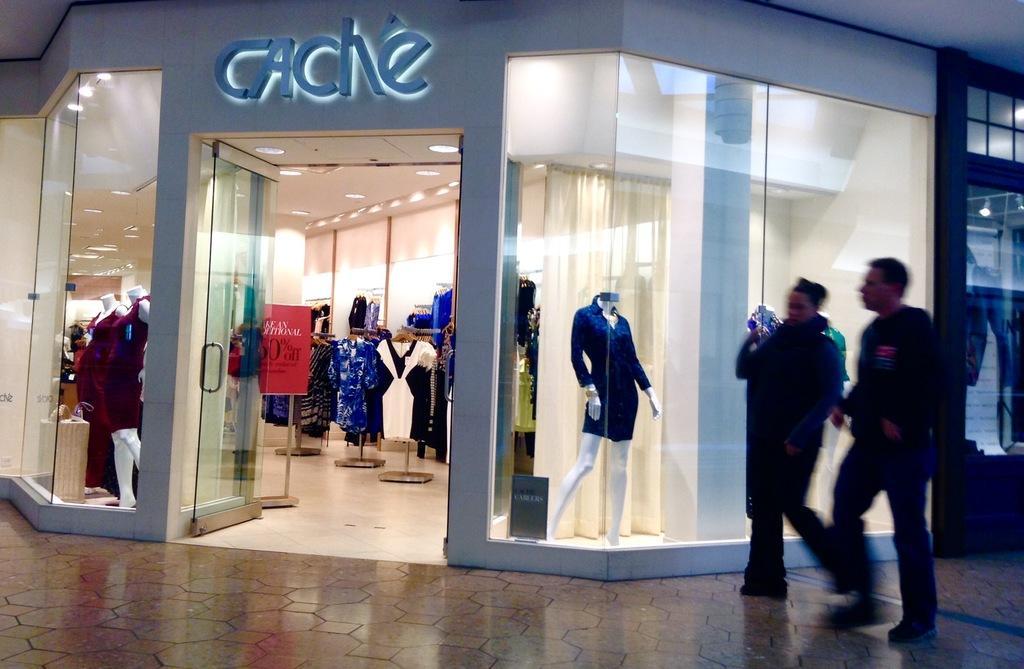In one or two sentences, can you explain what this image depicts? In this picture we can see couple of people in front of the store, in the store we can find few clothes, mannequins, lights and a hoarding. 